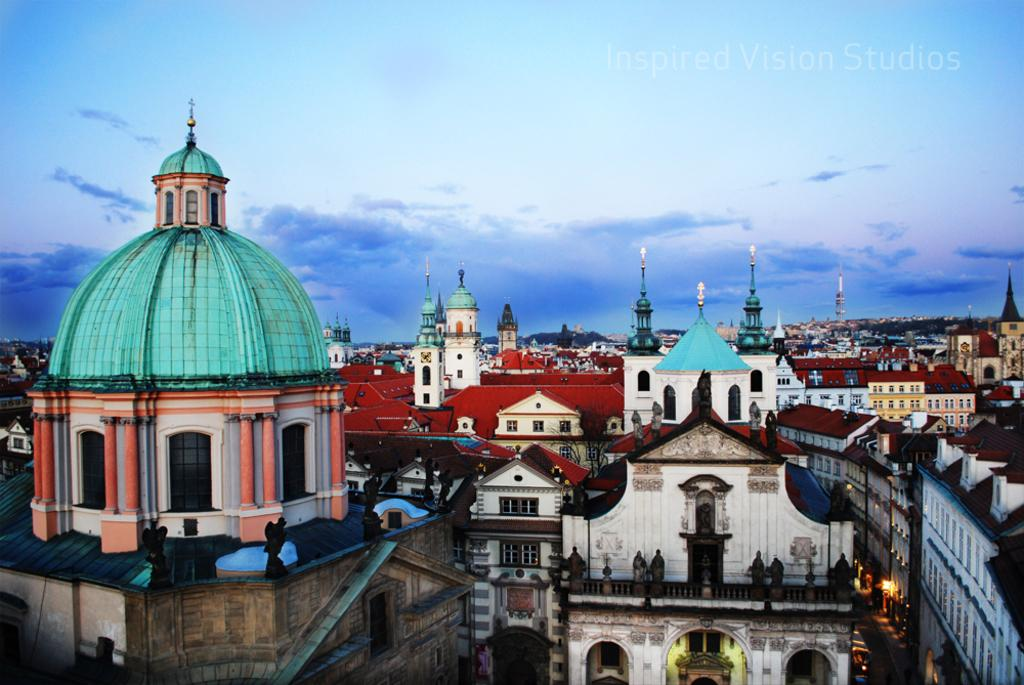What type of structures can be seen in the image? There are many buildings in the image. Are there any specific features of these buildings? Yes, there are towers in the image. What is visible in the sky in the image? Clouds are visible at the top of the image. What type of calendar is hanging on the wall of the tallest building in the image? There is no calendar visible in the image, and we cannot determine the type of calendar that might be hanging on the wall of the tallest building. 